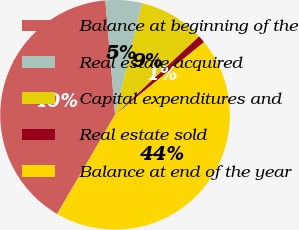Convert chart. <chart><loc_0><loc_0><loc_500><loc_500><pie_chart><fcel>Balance at beginning of the<fcel>Real estate acquired<fcel>Capital expenditures and<fcel>Real estate sold<fcel>Balance at end of the year<nl><fcel>40.23%<fcel>5.15%<fcel>9.25%<fcel>1.04%<fcel>44.33%<nl></chart> 